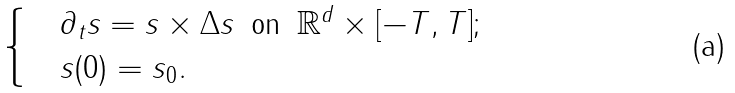<formula> <loc_0><loc_0><loc_500><loc_500>\begin{cases} & \partial _ { t } s = s \times \Delta s \, \text { on } \, \mathbb { R } ^ { d } \times [ - T , T ] ; \\ & s ( 0 ) = s _ { 0 } . \end{cases}</formula> 